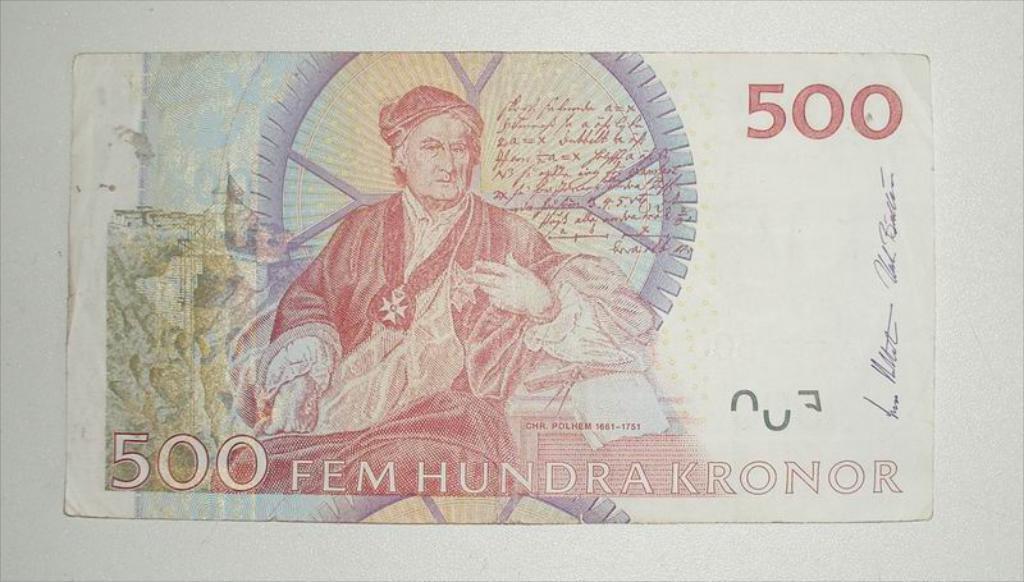Could you give a brief overview of what you see in this image? In this picture there is a photograph of the foreign currency note. On the front bottom side there is 500 written on it. 